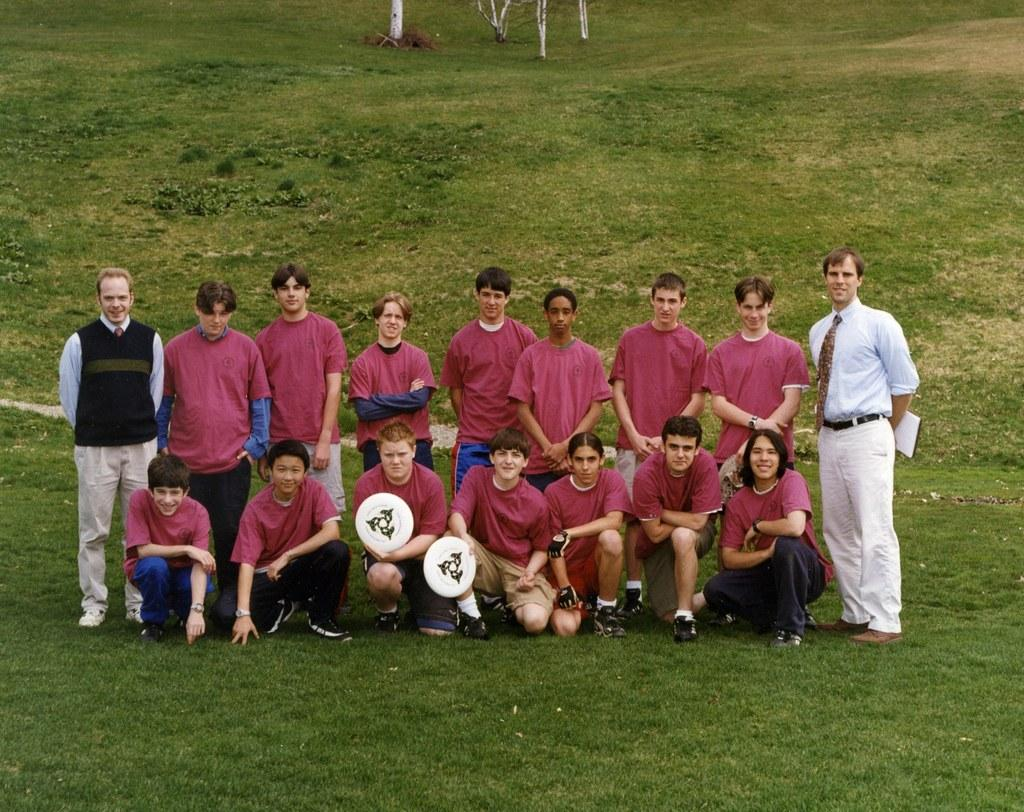How many people are present in the image? There are people in the image, but the exact number is not specified. What are two people holding in the image? Two people are holding objects, but the specific objects are not mentioned. What is the person holding in their hands? One person is holding papers. What type of vegetation can be seen in the image? There are plants and grass in the image. What type of trousers is the person wearing in the image? There is no information about the person's clothing in the image, so we cannot determine the type of trousers they are wearing. 